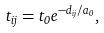<formula> <loc_0><loc_0><loc_500><loc_500>t _ { i j } = t _ { 0 } e ^ { - d _ { i j } / a _ { 0 } } ,</formula> 